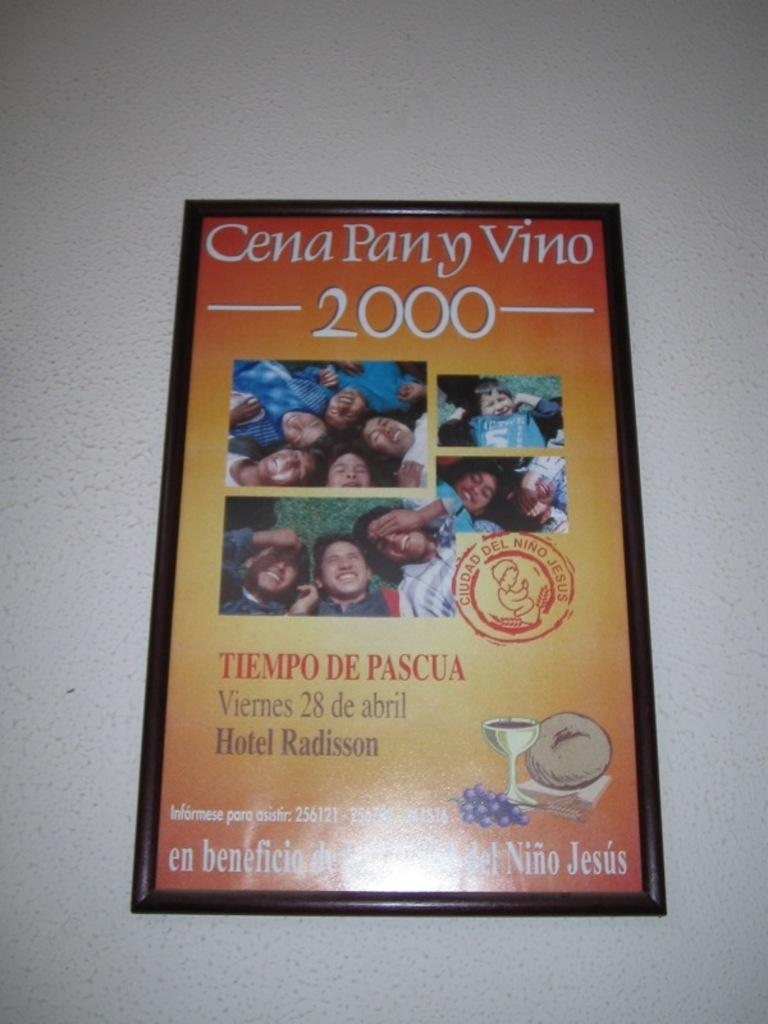<image>
Summarize the visual content of the image. A poster with the year 2000 on it 